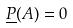<formula> <loc_0><loc_0><loc_500><loc_500>\underline { P } ( A ) = 0</formula> 